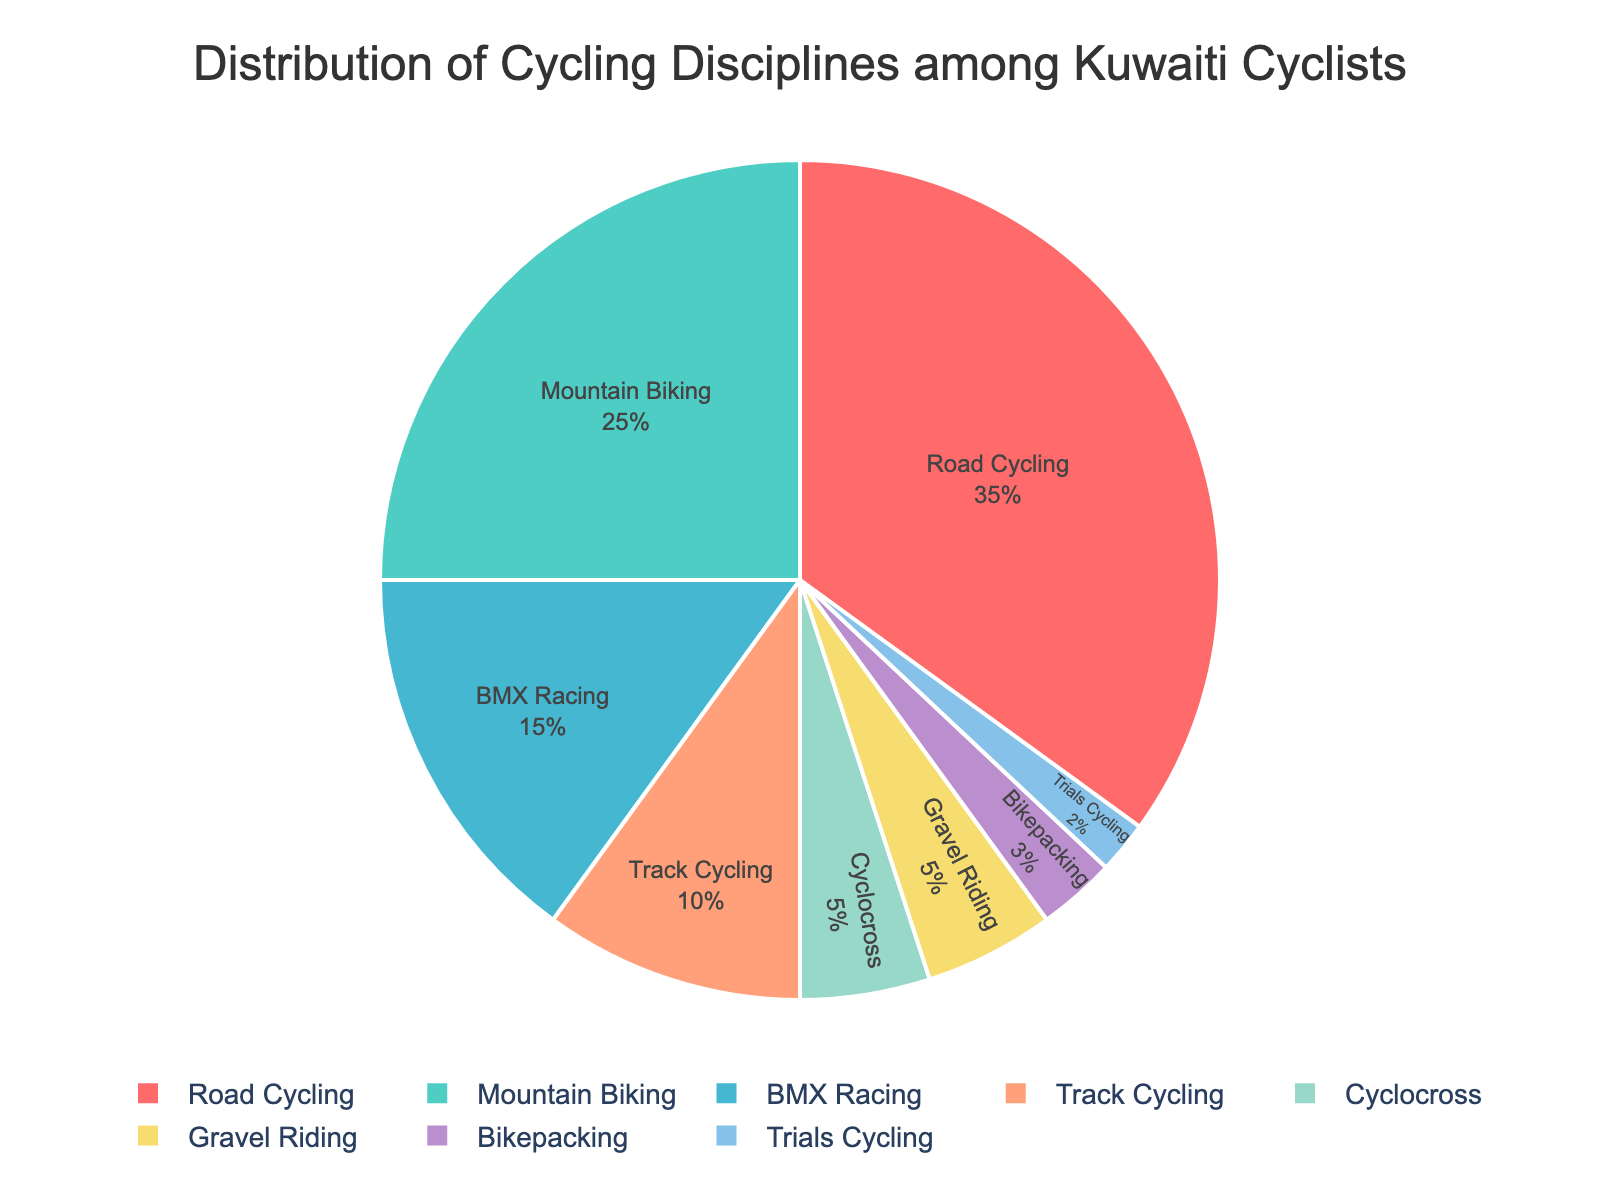Which discipline has the highest percentage among Kuwaiti cyclists? The pie chart shows that 'Road Cycling' has the largest portion.
Answer: Road Cycling What is the combined percentage of BMX Racing, Cyclocross, and Bikepacking? Add the percentages of BMX Racing (15%), Cyclocross (5%), and Bikepacking (3%) together: 15 + 5 + 3 = 23.
Answer: 23% Which two disciplines together make up 50% of the distribution? Combine percentages that add up to 50. Road Cycling (35%) and Mountain Biking (25%) together are 60%. Meanwhile, Road Cycling (35%) combined with Track Cycling (10%) and Cyclocross (5%) equals 50%.
Answer: Road Cycling and Mountain Biking Are there more Mountain Bikers or Track Cyclists? Compare the percentages of Mountain Biking (25%) and Track Cycling (10%). 25% is greater than 10%.
Answer: Mountain Bikers How many disciplines make up less than 10% each? Identify the disciplines with less than 10%: Track Cycling (10%, not less), Cyclocross (5%), Gravel Riding (5%), Bikepacking (3%), and Trials Cycling (2%). There are 4.
Answer: 4 Which disciplines have an equal percentage? Compare the segments and find equal percentages: Cyclocross and Gravel Riding both have 5%.
Answer: Cyclocross and Gravel Riding What is the difference in percentage between Road Cycling and Trials Cycling? Subtract the percentage of Trials Cycling (2%) from Road Cycling (35%): 35 - 2 = 33.
Answer: 33% If you combine Gravel Riding and Bikepacking, is their combined percentage higher than Track Cycling? Add percentages of Gravel Riding (5%) and Bikepacking (3%): 5 + 3 = 8. Compare with Track Cycling (10%). 8% is less than 10%.
Answer: No How much more popular is Road Cycling compared to BMX Racing? Subtract the percentage of BMX Racing (15%) from Road Cycling (35%): 35 - 15 = 20.
Answer: 20% Which discipline occupies a light blue color in the chart? Identify the segment colored light blue: BMX Racing.
Answer: BMX Racing 